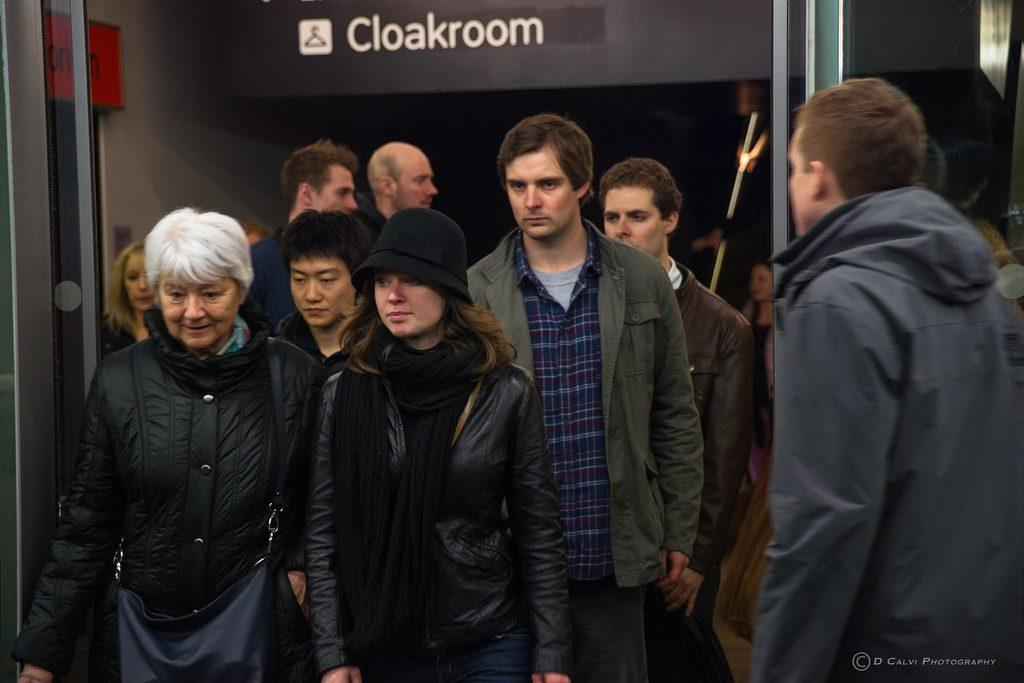How many people are in the image? There are many people in the image. What are the people wearing in the image? The people are wearing jackets. What are the people doing in the image? The people are standing and walking. What can be seen in the background of the image? There is a wall in the background of the image. What is written or depicted on the wall? There is text on the wall. What type of vacation is being advertised on the jar in the image? There is no jar present in the image, and therefore no vacation advertisement can be observed. How many trains are visible in the image? There are no trains visible in the image. 